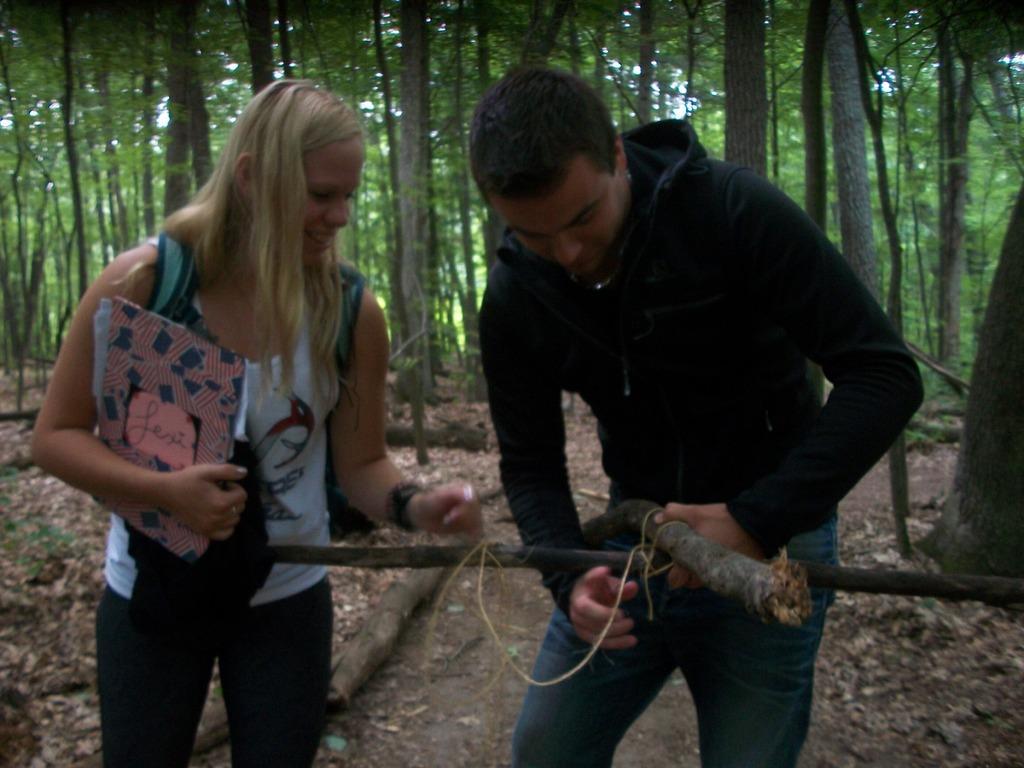Please provide a concise description of this image. In this picture we can observe a couple. One of them was a woman wearing white color dress and holding a file in her hand. She is smiling. The other was a man wearing black color hoodie and tying two wooden sticks together. We can observe dried leaves and wooden logs on the ground. In the background there are trees. 